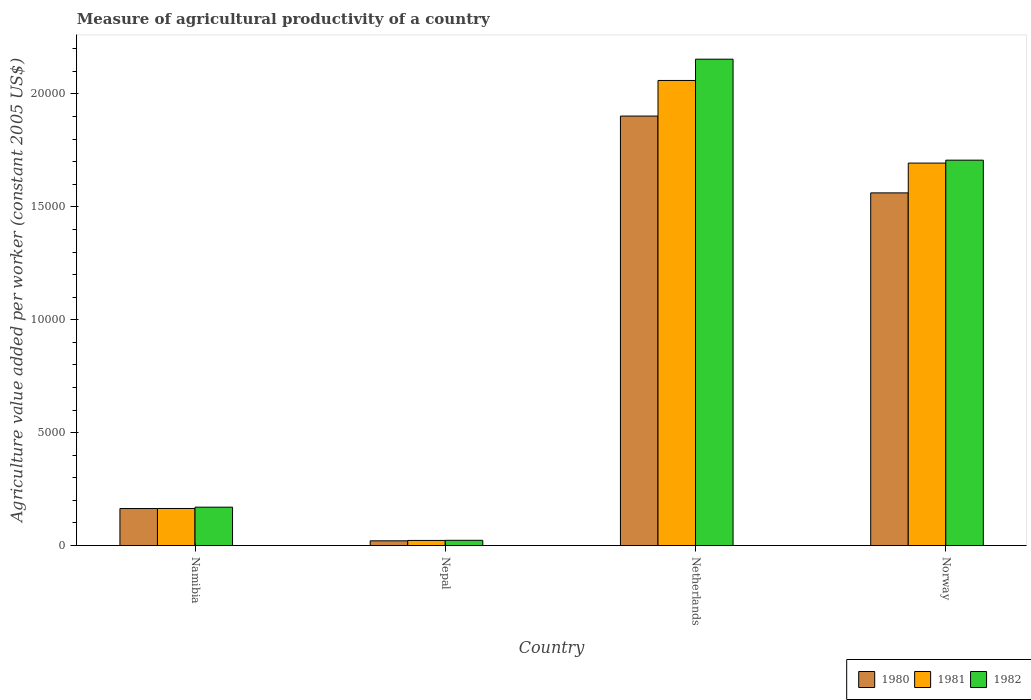How many different coloured bars are there?
Your response must be concise. 3. How many groups of bars are there?
Provide a short and direct response. 4. How many bars are there on the 4th tick from the left?
Your answer should be very brief. 3. How many bars are there on the 1st tick from the right?
Keep it short and to the point. 3. What is the label of the 2nd group of bars from the left?
Your answer should be very brief. Nepal. In how many cases, is the number of bars for a given country not equal to the number of legend labels?
Offer a very short reply. 0. What is the measure of agricultural productivity in 1982 in Netherlands?
Give a very brief answer. 2.15e+04. Across all countries, what is the maximum measure of agricultural productivity in 1982?
Your response must be concise. 2.15e+04. Across all countries, what is the minimum measure of agricultural productivity in 1980?
Keep it short and to the point. 210.09. In which country was the measure of agricultural productivity in 1982 maximum?
Offer a very short reply. Netherlands. In which country was the measure of agricultural productivity in 1980 minimum?
Ensure brevity in your answer.  Nepal. What is the total measure of agricultural productivity in 1982 in the graph?
Give a very brief answer. 4.05e+04. What is the difference between the measure of agricultural productivity in 1981 in Namibia and that in Norway?
Give a very brief answer. -1.53e+04. What is the difference between the measure of agricultural productivity in 1982 in Namibia and the measure of agricultural productivity in 1981 in Netherlands?
Give a very brief answer. -1.89e+04. What is the average measure of agricultural productivity in 1980 per country?
Your answer should be very brief. 9121.81. What is the difference between the measure of agricultural productivity of/in 1981 and measure of agricultural productivity of/in 1980 in Netherlands?
Offer a terse response. 1576.8. In how many countries, is the measure of agricultural productivity in 1981 greater than 1000 US$?
Offer a terse response. 3. What is the ratio of the measure of agricultural productivity in 1980 in Namibia to that in Nepal?
Your response must be concise. 7.8. What is the difference between the highest and the second highest measure of agricultural productivity in 1981?
Provide a short and direct response. 1.53e+04. What is the difference between the highest and the lowest measure of agricultural productivity in 1980?
Your answer should be compact. 1.88e+04. In how many countries, is the measure of agricultural productivity in 1980 greater than the average measure of agricultural productivity in 1980 taken over all countries?
Your answer should be very brief. 2. Is the sum of the measure of agricultural productivity in 1982 in Namibia and Netherlands greater than the maximum measure of agricultural productivity in 1980 across all countries?
Your answer should be compact. Yes. What does the 2nd bar from the left in Namibia represents?
Your response must be concise. 1981. What does the 3rd bar from the right in Netherlands represents?
Provide a short and direct response. 1980. How many countries are there in the graph?
Make the answer very short. 4. What is the difference between two consecutive major ticks on the Y-axis?
Provide a succinct answer. 5000. Does the graph contain any zero values?
Keep it short and to the point. No. Where does the legend appear in the graph?
Offer a terse response. Bottom right. How many legend labels are there?
Your response must be concise. 3. How are the legend labels stacked?
Ensure brevity in your answer.  Horizontal. What is the title of the graph?
Ensure brevity in your answer.  Measure of agricultural productivity of a country. What is the label or title of the X-axis?
Offer a very short reply. Country. What is the label or title of the Y-axis?
Ensure brevity in your answer.  Agriculture value added per worker (constant 2005 US$). What is the Agriculture value added per worker (constant 2005 US$) of 1980 in Namibia?
Your answer should be very brief. 1639.69. What is the Agriculture value added per worker (constant 2005 US$) of 1981 in Namibia?
Ensure brevity in your answer.  1642.55. What is the Agriculture value added per worker (constant 2005 US$) of 1982 in Namibia?
Your response must be concise. 1699.99. What is the Agriculture value added per worker (constant 2005 US$) in 1980 in Nepal?
Offer a very short reply. 210.09. What is the Agriculture value added per worker (constant 2005 US$) in 1981 in Nepal?
Provide a succinct answer. 227.07. What is the Agriculture value added per worker (constant 2005 US$) of 1982 in Nepal?
Provide a succinct answer. 232.83. What is the Agriculture value added per worker (constant 2005 US$) of 1980 in Netherlands?
Provide a short and direct response. 1.90e+04. What is the Agriculture value added per worker (constant 2005 US$) of 1981 in Netherlands?
Keep it short and to the point. 2.06e+04. What is the Agriculture value added per worker (constant 2005 US$) of 1982 in Netherlands?
Your response must be concise. 2.15e+04. What is the Agriculture value added per worker (constant 2005 US$) of 1980 in Norway?
Your response must be concise. 1.56e+04. What is the Agriculture value added per worker (constant 2005 US$) of 1981 in Norway?
Your response must be concise. 1.69e+04. What is the Agriculture value added per worker (constant 2005 US$) in 1982 in Norway?
Give a very brief answer. 1.71e+04. Across all countries, what is the maximum Agriculture value added per worker (constant 2005 US$) in 1980?
Offer a terse response. 1.90e+04. Across all countries, what is the maximum Agriculture value added per worker (constant 2005 US$) in 1981?
Give a very brief answer. 2.06e+04. Across all countries, what is the maximum Agriculture value added per worker (constant 2005 US$) of 1982?
Offer a terse response. 2.15e+04. Across all countries, what is the minimum Agriculture value added per worker (constant 2005 US$) of 1980?
Ensure brevity in your answer.  210.09. Across all countries, what is the minimum Agriculture value added per worker (constant 2005 US$) of 1981?
Provide a succinct answer. 227.07. Across all countries, what is the minimum Agriculture value added per worker (constant 2005 US$) in 1982?
Your answer should be compact. 232.83. What is the total Agriculture value added per worker (constant 2005 US$) of 1980 in the graph?
Your answer should be compact. 3.65e+04. What is the total Agriculture value added per worker (constant 2005 US$) of 1981 in the graph?
Keep it short and to the point. 3.94e+04. What is the total Agriculture value added per worker (constant 2005 US$) in 1982 in the graph?
Make the answer very short. 4.05e+04. What is the difference between the Agriculture value added per worker (constant 2005 US$) in 1980 in Namibia and that in Nepal?
Provide a succinct answer. 1429.6. What is the difference between the Agriculture value added per worker (constant 2005 US$) of 1981 in Namibia and that in Nepal?
Your answer should be compact. 1415.48. What is the difference between the Agriculture value added per worker (constant 2005 US$) of 1982 in Namibia and that in Nepal?
Your response must be concise. 1467.16. What is the difference between the Agriculture value added per worker (constant 2005 US$) of 1980 in Namibia and that in Netherlands?
Offer a very short reply. -1.74e+04. What is the difference between the Agriculture value added per worker (constant 2005 US$) in 1981 in Namibia and that in Netherlands?
Offer a very short reply. -1.90e+04. What is the difference between the Agriculture value added per worker (constant 2005 US$) of 1982 in Namibia and that in Netherlands?
Make the answer very short. -1.98e+04. What is the difference between the Agriculture value added per worker (constant 2005 US$) of 1980 in Namibia and that in Norway?
Keep it short and to the point. -1.40e+04. What is the difference between the Agriculture value added per worker (constant 2005 US$) in 1981 in Namibia and that in Norway?
Provide a short and direct response. -1.53e+04. What is the difference between the Agriculture value added per worker (constant 2005 US$) in 1982 in Namibia and that in Norway?
Ensure brevity in your answer.  -1.54e+04. What is the difference between the Agriculture value added per worker (constant 2005 US$) in 1980 in Nepal and that in Netherlands?
Ensure brevity in your answer.  -1.88e+04. What is the difference between the Agriculture value added per worker (constant 2005 US$) of 1981 in Nepal and that in Netherlands?
Provide a short and direct response. -2.04e+04. What is the difference between the Agriculture value added per worker (constant 2005 US$) in 1982 in Nepal and that in Netherlands?
Give a very brief answer. -2.13e+04. What is the difference between the Agriculture value added per worker (constant 2005 US$) of 1980 in Nepal and that in Norway?
Ensure brevity in your answer.  -1.54e+04. What is the difference between the Agriculture value added per worker (constant 2005 US$) in 1981 in Nepal and that in Norway?
Provide a short and direct response. -1.67e+04. What is the difference between the Agriculture value added per worker (constant 2005 US$) of 1982 in Nepal and that in Norway?
Offer a terse response. -1.68e+04. What is the difference between the Agriculture value added per worker (constant 2005 US$) of 1980 in Netherlands and that in Norway?
Provide a short and direct response. 3401.71. What is the difference between the Agriculture value added per worker (constant 2005 US$) of 1981 in Netherlands and that in Norway?
Your response must be concise. 3658.56. What is the difference between the Agriculture value added per worker (constant 2005 US$) of 1982 in Netherlands and that in Norway?
Your answer should be compact. 4471.16. What is the difference between the Agriculture value added per worker (constant 2005 US$) in 1980 in Namibia and the Agriculture value added per worker (constant 2005 US$) in 1981 in Nepal?
Provide a succinct answer. 1412.62. What is the difference between the Agriculture value added per worker (constant 2005 US$) of 1980 in Namibia and the Agriculture value added per worker (constant 2005 US$) of 1982 in Nepal?
Offer a terse response. 1406.86. What is the difference between the Agriculture value added per worker (constant 2005 US$) of 1981 in Namibia and the Agriculture value added per worker (constant 2005 US$) of 1982 in Nepal?
Your answer should be compact. 1409.72. What is the difference between the Agriculture value added per worker (constant 2005 US$) of 1980 in Namibia and the Agriculture value added per worker (constant 2005 US$) of 1981 in Netherlands?
Give a very brief answer. -1.90e+04. What is the difference between the Agriculture value added per worker (constant 2005 US$) of 1980 in Namibia and the Agriculture value added per worker (constant 2005 US$) of 1982 in Netherlands?
Provide a short and direct response. -1.99e+04. What is the difference between the Agriculture value added per worker (constant 2005 US$) of 1981 in Namibia and the Agriculture value added per worker (constant 2005 US$) of 1982 in Netherlands?
Give a very brief answer. -1.99e+04. What is the difference between the Agriculture value added per worker (constant 2005 US$) of 1980 in Namibia and the Agriculture value added per worker (constant 2005 US$) of 1981 in Norway?
Provide a short and direct response. -1.53e+04. What is the difference between the Agriculture value added per worker (constant 2005 US$) of 1980 in Namibia and the Agriculture value added per worker (constant 2005 US$) of 1982 in Norway?
Your answer should be compact. -1.54e+04. What is the difference between the Agriculture value added per worker (constant 2005 US$) in 1981 in Namibia and the Agriculture value added per worker (constant 2005 US$) in 1982 in Norway?
Keep it short and to the point. -1.54e+04. What is the difference between the Agriculture value added per worker (constant 2005 US$) of 1980 in Nepal and the Agriculture value added per worker (constant 2005 US$) of 1981 in Netherlands?
Offer a terse response. -2.04e+04. What is the difference between the Agriculture value added per worker (constant 2005 US$) in 1980 in Nepal and the Agriculture value added per worker (constant 2005 US$) in 1982 in Netherlands?
Provide a succinct answer. -2.13e+04. What is the difference between the Agriculture value added per worker (constant 2005 US$) in 1981 in Nepal and the Agriculture value added per worker (constant 2005 US$) in 1982 in Netherlands?
Ensure brevity in your answer.  -2.13e+04. What is the difference between the Agriculture value added per worker (constant 2005 US$) in 1980 in Nepal and the Agriculture value added per worker (constant 2005 US$) in 1981 in Norway?
Your answer should be compact. -1.67e+04. What is the difference between the Agriculture value added per worker (constant 2005 US$) of 1980 in Nepal and the Agriculture value added per worker (constant 2005 US$) of 1982 in Norway?
Make the answer very short. -1.69e+04. What is the difference between the Agriculture value added per worker (constant 2005 US$) in 1981 in Nepal and the Agriculture value added per worker (constant 2005 US$) in 1982 in Norway?
Provide a short and direct response. -1.68e+04. What is the difference between the Agriculture value added per worker (constant 2005 US$) of 1980 in Netherlands and the Agriculture value added per worker (constant 2005 US$) of 1981 in Norway?
Keep it short and to the point. 2081.76. What is the difference between the Agriculture value added per worker (constant 2005 US$) of 1980 in Netherlands and the Agriculture value added per worker (constant 2005 US$) of 1982 in Norway?
Ensure brevity in your answer.  1952.22. What is the difference between the Agriculture value added per worker (constant 2005 US$) of 1981 in Netherlands and the Agriculture value added per worker (constant 2005 US$) of 1982 in Norway?
Make the answer very short. 3529.02. What is the average Agriculture value added per worker (constant 2005 US$) in 1980 per country?
Ensure brevity in your answer.  9121.81. What is the average Agriculture value added per worker (constant 2005 US$) in 1981 per country?
Keep it short and to the point. 9850.96. What is the average Agriculture value added per worker (constant 2005 US$) in 1982 per country?
Provide a succinct answer. 1.01e+04. What is the difference between the Agriculture value added per worker (constant 2005 US$) of 1980 and Agriculture value added per worker (constant 2005 US$) of 1981 in Namibia?
Offer a very short reply. -2.86. What is the difference between the Agriculture value added per worker (constant 2005 US$) of 1980 and Agriculture value added per worker (constant 2005 US$) of 1982 in Namibia?
Provide a succinct answer. -60.3. What is the difference between the Agriculture value added per worker (constant 2005 US$) in 1981 and Agriculture value added per worker (constant 2005 US$) in 1982 in Namibia?
Offer a terse response. -57.44. What is the difference between the Agriculture value added per worker (constant 2005 US$) of 1980 and Agriculture value added per worker (constant 2005 US$) of 1981 in Nepal?
Provide a short and direct response. -16.98. What is the difference between the Agriculture value added per worker (constant 2005 US$) in 1980 and Agriculture value added per worker (constant 2005 US$) in 1982 in Nepal?
Provide a succinct answer. -22.74. What is the difference between the Agriculture value added per worker (constant 2005 US$) in 1981 and Agriculture value added per worker (constant 2005 US$) in 1982 in Nepal?
Offer a terse response. -5.76. What is the difference between the Agriculture value added per worker (constant 2005 US$) of 1980 and Agriculture value added per worker (constant 2005 US$) of 1981 in Netherlands?
Make the answer very short. -1576.8. What is the difference between the Agriculture value added per worker (constant 2005 US$) of 1980 and Agriculture value added per worker (constant 2005 US$) of 1982 in Netherlands?
Offer a terse response. -2518.94. What is the difference between the Agriculture value added per worker (constant 2005 US$) of 1981 and Agriculture value added per worker (constant 2005 US$) of 1982 in Netherlands?
Provide a succinct answer. -942.14. What is the difference between the Agriculture value added per worker (constant 2005 US$) of 1980 and Agriculture value added per worker (constant 2005 US$) of 1981 in Norway?
Ensure brevity in your answer.  -1319.95. What is the difference between the Agriculture value added per worker (constant 2005 US$) of 1980 and Agriculture value added per worker (constant 2005 US$) of 1982 in Norway?
Ensure brevity in your answer.  -1449.49. What is the difference between the Agriculture value added per worker (constant 2005 US$) of 1981 and Agriculture value added per worker (constant 2005 US$) of 1982 in Norway?
Give a very brief answer. -129.54. What is the ratio of the Agriculture value added per worker (constant 2005 US$) of 1980 in Namibia to that in Nepal?
Offer a very short reply. 7.8. What is the ratio of the Agriculture value added per worker (constant 2005 US$) in 1981 in Namibia to that in Nepal?
Keep it short and to the point. 7.23. What is the ratio of the Agriculture value added per worker (constant 2005 US$) in 1982 in Namibia to that in Nepal?
Give a very brief answer. 7.3. What is the ratio of the Agriculture value added per worker (constant 2005 US$) in 1980 in Namibia to that in Netherlands?
Your answer should be compact. 0.09. What is the ratio of the Agriculture value added per worker (constant 2005 US$) in 1981 in Namibia to that in Netherlands?
Your answer should be very brief. 0.08. What is the ratio of the Agriculture value added per worker (constant 2005 US$) in 1982 in Namibia to that in Netherlands?
Keep it short and to the point. 0.08. What is the ratio of the Agriculture value added per worker (constant 2005 US$) in 1980 in Namibia to that in Norway?
Your answer should be compact. 0.1. What is the ratio of the Agriculture value added per worker (constant 2005 US$) of 1981 in Namibia to that in Norway?
Offer a very short reply. 0.1. What is the ratio of the Agriculture value added per worker (constant 2005 US$) of 1982 in Namibia to that in Norway?
Offer a terse response. 0.1. What is the ratio of the Agriculture value added per worker (constant 2005 US$) of 1980 in Nepal to that in Netherlands?
Your answer should be very brief. 0.01. What is the ratio of the Agriculture value added per worker (constant 2005 US$) in 1981 in Nepal to that in Netherlands?
Ensure brevity in your answer.  0.01. What is the ratio of the Agriculture value added per worker (constant 2005 US$) of 1982 in Nepal to that in Netherlands?
Offer a terse response. 0.01. What is the ratio of the Agriculture value added per worker (constant 2005 US$) of 1980 in Nepal to that in Norway?
Keep it short and to the point. 0.01. What is the ratio of the Agriculture value added per worker (constant 2005 US$) of 1981 in Nepal to that in Norway?
Ensure brevity in your answer.  0.01. What is the ratio of the Agriculture value added per worker (constant 2005 US$) in 1982 in Nepal to that in Norway?
Offer a very short reply. 0.01. What is the ratio of the Agriculture value added per worker (constant 2005 US$) of 1980 in Netherlands to that in Norway?
Make the answer very short. 1.22. What is the ratio of the Agriculture value added per worker (constant 2005 US$) of 1981 in Netherlands to that in Norway?
Your answer should be compact. 1.22. What is the ratio of the Agriculture value added per worker (constant 2005 US$) in 1982 in Netherlands to that in Norway?
Your answer should be compact. 1.26. What is the difference between the highest and the second highest Agriculture value added per worker (constant 2005 US$) of 1980?
Your response must be concise. 3401.71. What is the difference between the highest and the second highest Agriculture value added per worker (constant 2005 US$) in 1981?
Your answer should be very brief. 3658.56. What is the difference between the highest and the second highest Agriculture value added per worker (constant 2005 US$) in 1982?
Your answer should be compact. 4471.16. What is the difference between the highest and the lowest Agriculture value added per worker (constant 2005 US$) of 1980?
Keep it short and to the point. 1.88e+04. What is the difference between the highest and the lowest Agriculture value added per worker (constant 2005 US$) of 1981?
Offer a terse response. 2.04e+04. What is the difference between the highest and the lowest Agriculture value added per worker (constant 2005 US$) of 1982?
Your response must be concise. 2.13e+04. 